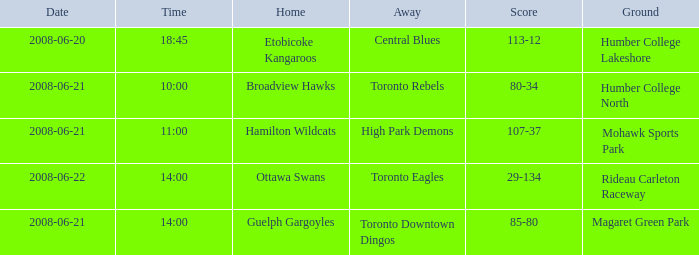What is the date with a dwelling that is hamilton wildcats? 2008-06-21. 